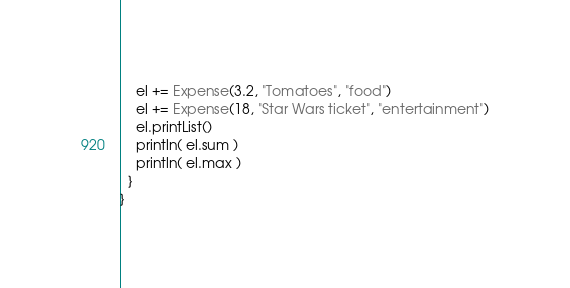Convert code to text. <code><loc_0><loc_0><loc_500><loc_500><_Scala_>    el += Expense(3.2, "Tomatoes", "food")
    el += Expense(18, "Star Wars ticket", "entertainment")
    el.printList()
    println( el.sum )
    println( el.max )
  }
}
</code> 